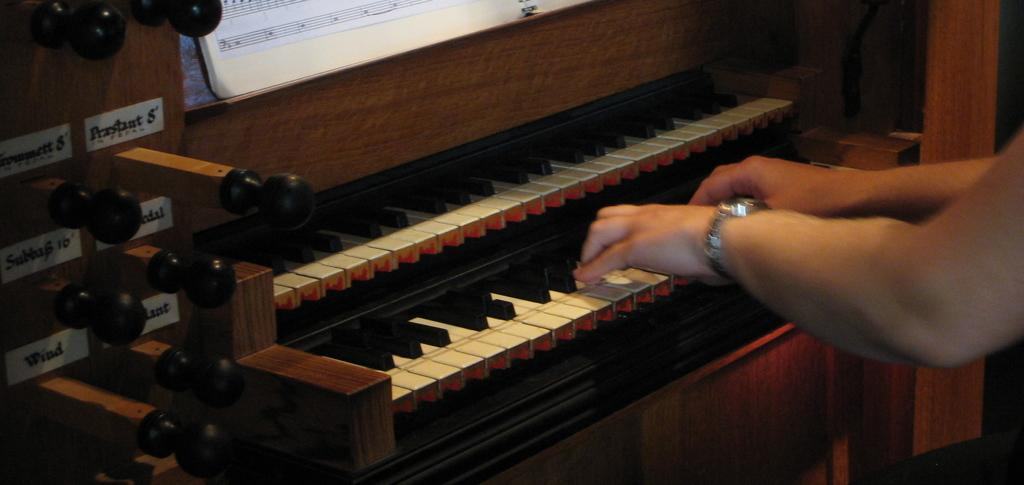What is the person's hand doing in the image? The person's hand is on a piano in the image. What other object can be seen in the image besides the piano? There is a book visible in the image. What type of juice is being squeezed out of the balloon in the image? There is no juice or balloon present in the image; it only features a person's hand on a piano and a book. 